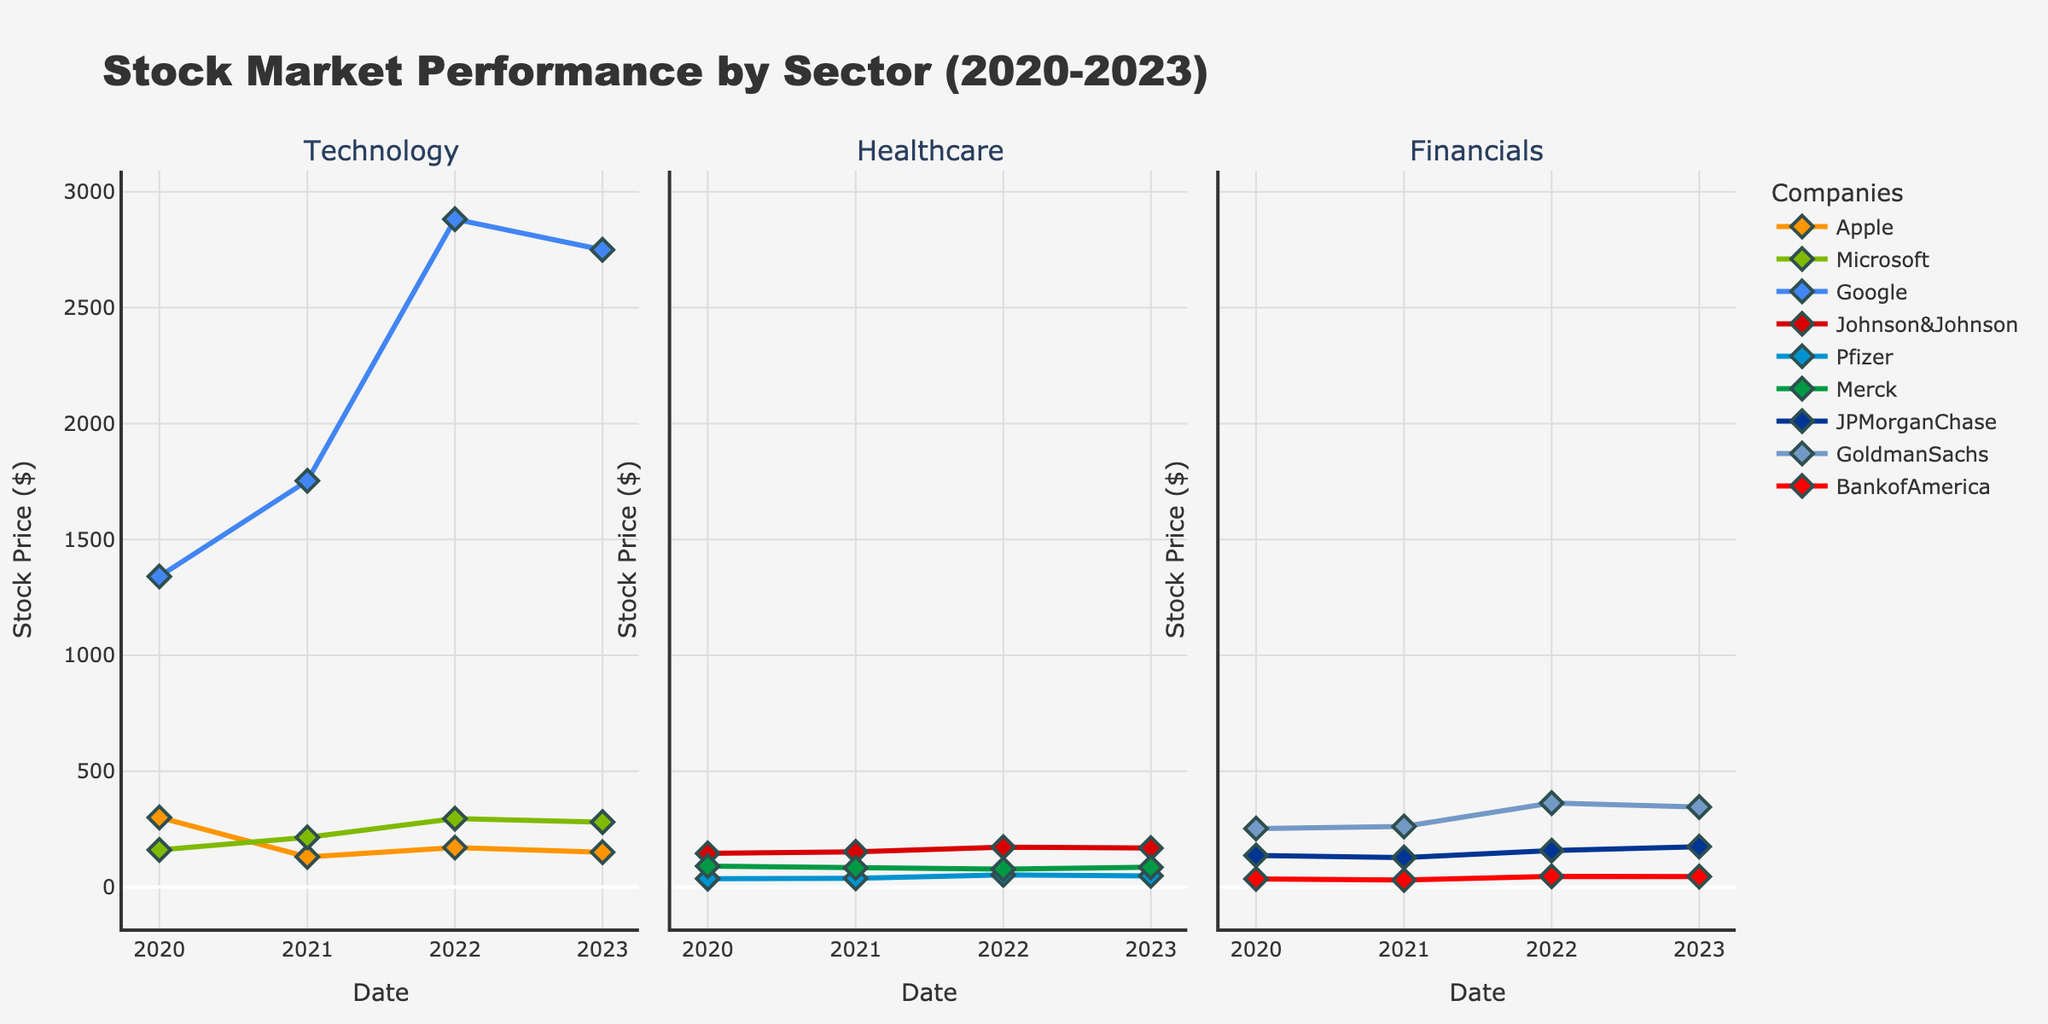What is the title of the figure? The title of the figure is usually displayed prominently at the top of the plot. In this case, the title is positioned to give a clear indication of what the figure represents.
Answer: Stock Market Performance by Sector (2020-2023) Which sector shows the highest stock price for a single company in 2022? To determine this, look at the highest point on the y-axis for each subplot (sector) in 2022. For Technology, Google has the highest stock price of 2882. For Healthcare, Johnson & Johnson has a stock price of 172. For Financials, Goldman Sachs has a stock price of 362. Comparing these, Google in the Technology sector has the highest stock price.
Answer: Technology How many companies are represented in the Financials sector subplot? To find this, look for the legend or the different colored markers/lines in the Financials sector subplot. Each unique color represents a different company.
Answer: 3 Which company in the Technology sector saw a decrease in stock price from 2022 to 2023? Examine the Technology subplot, focusing on the markers/lines for each company from 2022 to 2023. Identify which company’s stock price dropped during this period.
Answer: Apple What is the color representing Johnson & Johnson in the Healthcare sector? Locate the legend or the colored lines and markers in the Healthcare subplot. Match Johnson & Johnson to its corresponding color.
Answer: Red Between 2020 and 2023, which sector shows the most overall increase in stock prices across its companies? First, calculate the difference in stock prices from 2020 to 2023 for each company. Then sum these differences for each sector and compare the totals to see which sector has the highest overall increase. Detailed explanation: For Technology, the increase for Apple is -150 (300 to 150), Microsoft is 120 (160 to 280), Google is 1410 (1340 to 2750); for Healthcare, Johnson & Johnson is 23 (145 to 168), Pfizer is 12 (36 to 48), Merck is -5 (90 to 85); for Financials, JPMorganChase is 38 (136 to 174), GoldmanSachs is 93 (252 to 345), BankofAmerica is 10 (35 to 45). Adding these up, Technology sector shows the highest increase.
Answer: Technology Which company's stock price showed the least variation in the Healthcare sector? Calculate the range (maximum - minimum) of stock prices for each company in the Healthcare sector. Compare these ranges to determine the company with the smallest range. Detailed explanation: Johnson & Johnson (172 - 145 = 27), Pfizer (52 - 36 = 16), Merck (90 - 77 = 13). Merck shows the least variation.
Answer: Merck In 2021, which sector had the lowest stock price among all the companies? Check the minimum stock price for each company in all three subplots (sectors) for the year 2021. Identify the lowest value and the corresponding sector.
Answer: Financials Did Goldman Sachs’ stock price ever surpass 300 during the span of 2020 to 2023? Observe the line/markers representing Goldman Sachs in the Financials sector subplot. Look if any points cross the 300 mark on the y-axis.
Answer: Yes 